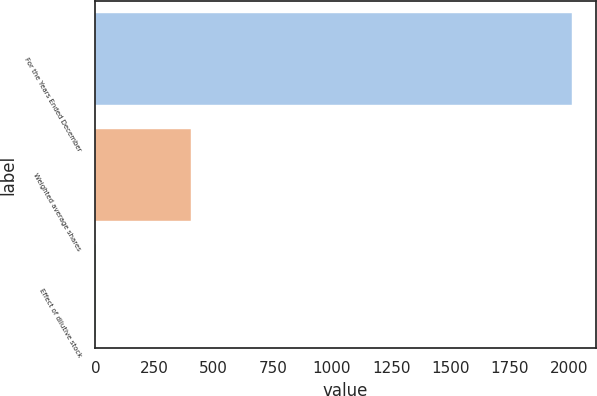Convert chart to OTSL. <chart><loc_0><loc_0><loc_500><loc_500><bar_chart><fcel>For the Years Ended December<fcel>Weighted average shares<fcel>Effect of dilutive stock<nl><fcel>2014<fcel>404.96<fcel>2.7<nl></chart> 